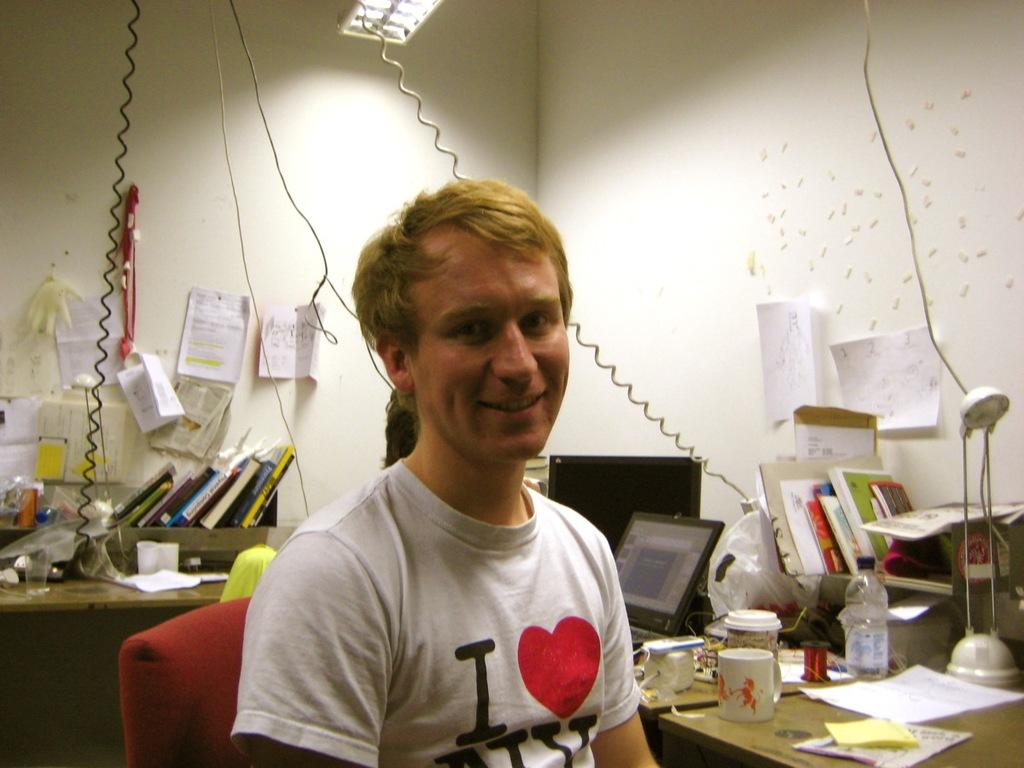What city does he love?
Your answer should be very brief. Ny. Who loves ny?
Your answer should be very brief. I. 